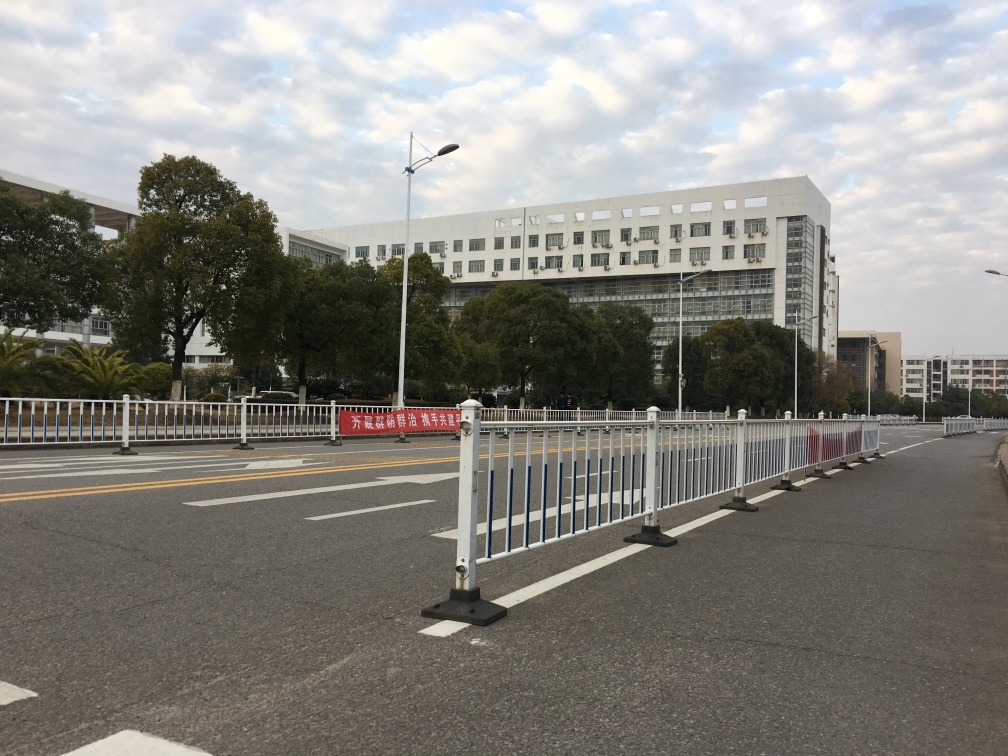Are there any focusing issues in the image? The image appears to be well-focused, with clear details across various distances - from the road markings close to the camera to the building structure in the background. Even the textures on the road surface and the guardrails are distinct, indicating that the camera's focus has been properly set to capture a sharp image. 